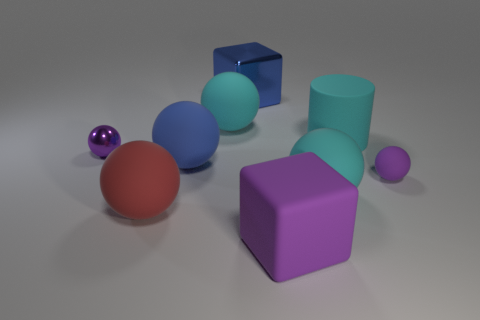Subtract all cyan spheres. How many spheres are left? 4 Subtract all red balls. How many balls are left? 5 Subtract all cylinders. How many objects are left? 8 Subtract 1 cylinders. How many cylinders are left? 0 Subtract all brown cylinders. Subtract all green balls. How many cylinders are left? 1 Subtract all purple rubber objects. Subtract all tiny purple things. How many objects are left? 5 Add 2 large metallic objects. How many large metallic objects are left? 3 Add 7 cyan rubber blocks. How many cyan rubber blocks exist? 7 Subtract 1 purple cubes. How many objects are left? 8 Subtract all gray blocks. How many blue balls are left? 1 